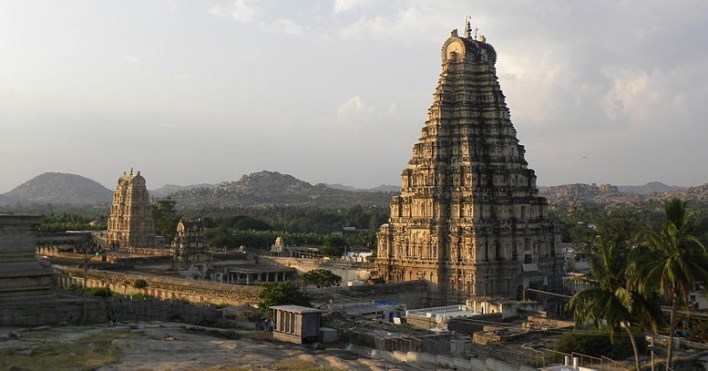Explain the visual content of the image in great detail. The image captures the grandeur of the Virupaksha Temple, a UNESCO World Heritage Site located in Hampi, India. The temple, dedicated to the Hindu deity Shiva, stands tall against the backdrop of a clear blue sky. The photo is taken from a distance, allowing the viewer to appreciate the temple's ornate tower, known as a gopuram. The gopuram, covered in intricate carvings, reaches towards the heavens, a testament to the architectural prowess of the artisans who built it.

The temple is surrounded by smaller structures and ruins, remnants of a bygone era that add to the historical significance of the site. The landscape around the temple is dotted with palm trees and boulders, adding a touch of natural beauty to the scene. The photo is taken at sunset, and the warm glow of the setting sun bathes the temple and its surroundings in a soft, golden light, enhancing the overall visual appeal of the scene. The image is a beautiful blend of history, architecture, and nature, perfectly capturing the essence of this iconic landmark. 